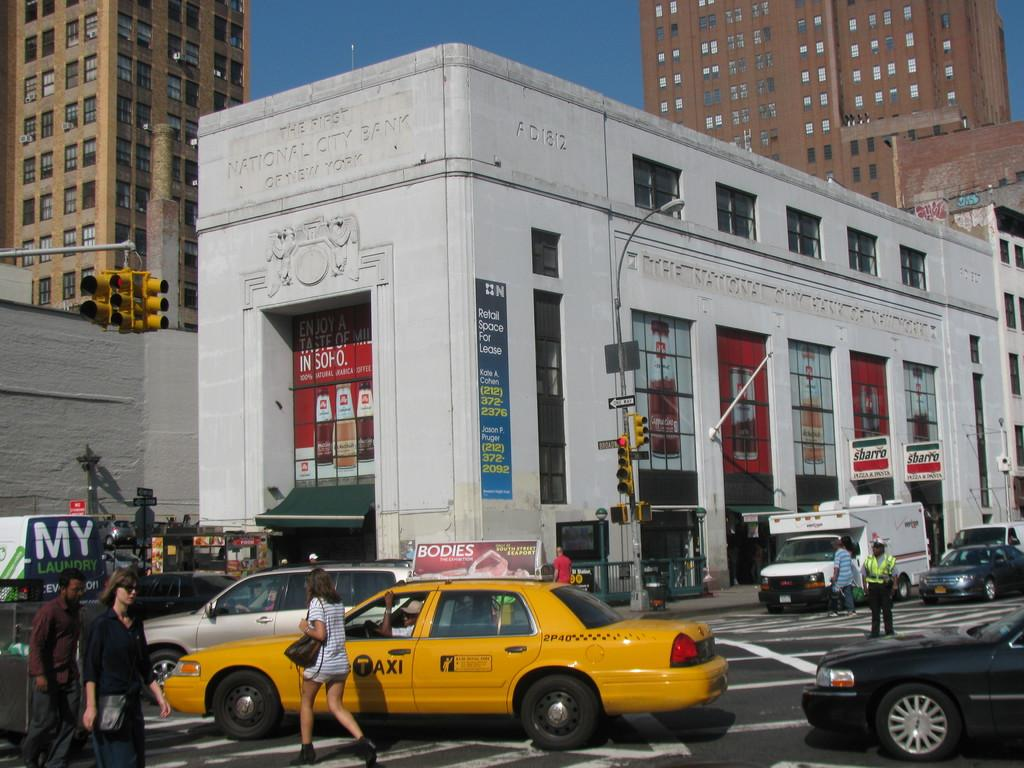<image>
Create a compact narrative representing the image presented. People are crossing a busy stret while a yellow cab with a label "TAXI" drives by them. 